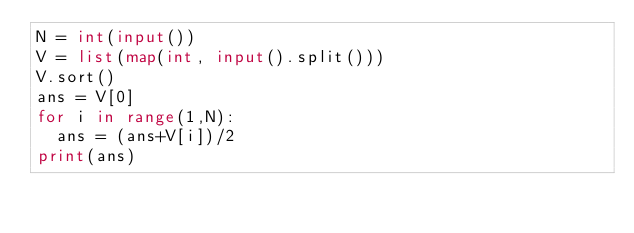<code> <loc_0><loc_0><loc_500><loc_500><_Python_>N = int(input())
V = list(map(int, input().split()))
V.sort()
ans = V[0]
for i in range(1,N):
  ans = (ans+V[i])/2
print(ans)</code> 